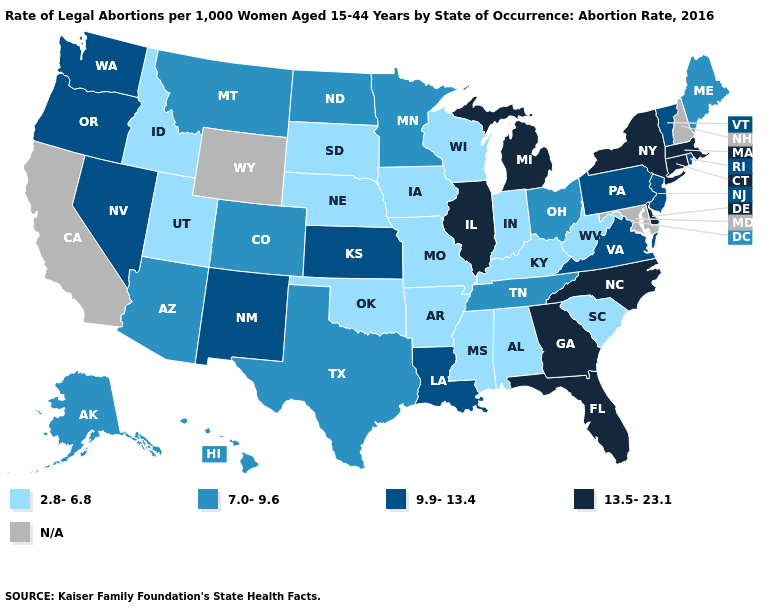Among the states that border Mississippi , does Alabama have the lowest value?
Write a very short answer. Yes. Does the map have missing data?
Short answer required. Yes. What is the lowest value in the South?
Quick response, please. 2.8-6.8. Name the states that have a value in the range N/A?
Short answer required. California, Maryland, New Hampshire, Wyoming. Does Texas have the lowest value in the USA?
Quick response, please. No. What is the highest value in the South ?
Short answer required. 13.5-23.1. Which states have the lowest value in the MidWest?
Concise answer only. Indiana, Iowa, Missouri, Nebraska, South Dakota, Wisconsin. Name the states that have a value in the range 13.5-23.1?
Concise answer only. Connecticut, Delaware, Florida, Georgia, Illinois, Massachusetts, Michigan, New York, North Carolina. Name the states that have a value in the range 9.9-13.4?
Answer briefly. Kansas, Louisiana, Nevada, New Jersey, New Mexico, Oregon, Pennsylvania, Rhode Island, Vermont, Virginia, Washington. Among the states that border California , does Arizona have the lowest value?
Quick response, please. Yes. Which states hav the highest value in the West?
Short answer required. Nevada, New Mexico, Oregon, Washington. Among the states that border Rhode Island , which have the lowest value?
Answer briefly. Connecticut, Massachusetts. What is the value of Rhode Island?
Give a very brief answer. 9.9-13.4. What is the value of Maryland?
Keep it brief. N/A. 